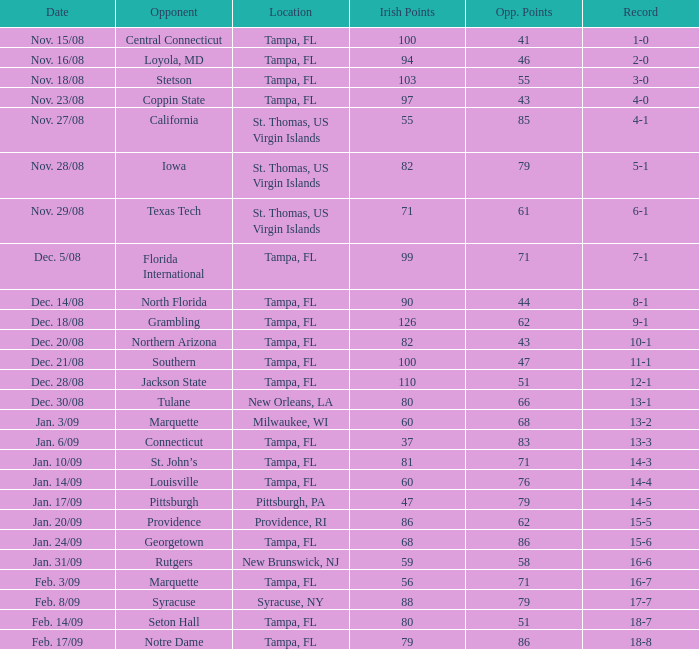Can you give me this table as a dict? {'header': ['Date', 'Opponent', 'Location', 'Irish Points', 'Opp. Points', 'Record'], 'rows': [['Nov. 15/08', 'Central Connecticut', 'Tampa, FL', '100', '41', '1-0'], ['Nov. 16/08', 'Loyola, MD', 'Tampa, FL', '94', '46', '2-0'], ['Nov. 18/08', 'Stetson', 'Tampa, FL', '103', '55', '3-0'], ['Nov. 23/08', 'Coppin State', 'Tampa, FL', '97', '43', '4-0'], ['Nov. 27/08', 'California', 'St. Thomas, US Virgin Islands', '55', '85', '4-1'], ['Nov. 28/08', 'Iowa', 'St. Thomas, US Virgin Islands', '82', '79', '5-1'], ['Nov. 29/08', 'Texas Tech', 'St. Thomas, US Virgin Islands', '71', '61', '6-1'], ['Dec. 5/08', 'Florida International', 'Tampa, FL', '99', '71', '7-1'], ['Dec. 14/08', 'North Florida', 'Tampa, FL', '90', '44', '8-1'], ['Dec. 18/08', 'Grambling', 'Tampa, FL', '126', '62', '9-1'], ['Dec. 20/08', 'Northern Arizona', 'Tampa, FL', '82', '43', '10-1'], ['Dec. 21/08', 'Southern', 'Tampa, FL', '100', '47', '11-1'], ['Dec. 28/08', 'Jackson State', 'Tampa, FL', '110', '51', '12-1'], ['Dec. 30/08', 'Tulane', 'New Orleans, LA', '80', '66', '13-1'], ['Jan. 3/09', 'Marquette', 'Milwaukee, WI', '60', '68', '13-2'], ['Jan. 6/09', 'Connecticut', 'Tampa, FL', '37', '83', '13-3'], ['Jan. 10/09', 'St. John’s', 'Tampa, FL', '81', '71', '14-3'], ['Jan. 14/09', 'Louisville', 'Tampa, FL', '60', '76', '14-4'], ['Jan. 17/09', 'Pittsburgh', 'Pittsburgh, PA', '47', '79', '14-5'], ['Jan. 20/09', 'Providence', 'Providence, RI', '86', '62', '15-5'], ['Jan. 24/09', 'Georgetown', 'Tampa, FL', '68', '86', '15-6'], ['Jan. 31/09', 'Rutgers', 'New Brunswick, NJ', '59', '58', '16-6'], ['Feb. 3/09', 'Marquette', 'Tampa, FL', '56', '71', '16-7'], ['Feb. 8/09', 'Syracuse', 'Syracuse, NY', '88', '79', '17-7'], ['Feb. 14/09', 'Seton Hall', 'Tampa, FL', '80', '51', '18-7'], ['Feb. 17/09', 'Notre Dame', 'Tampa, FL', '79', '86', '18-8']]} What is the number of opponents where the location is syracuse, ny? 1.0. 